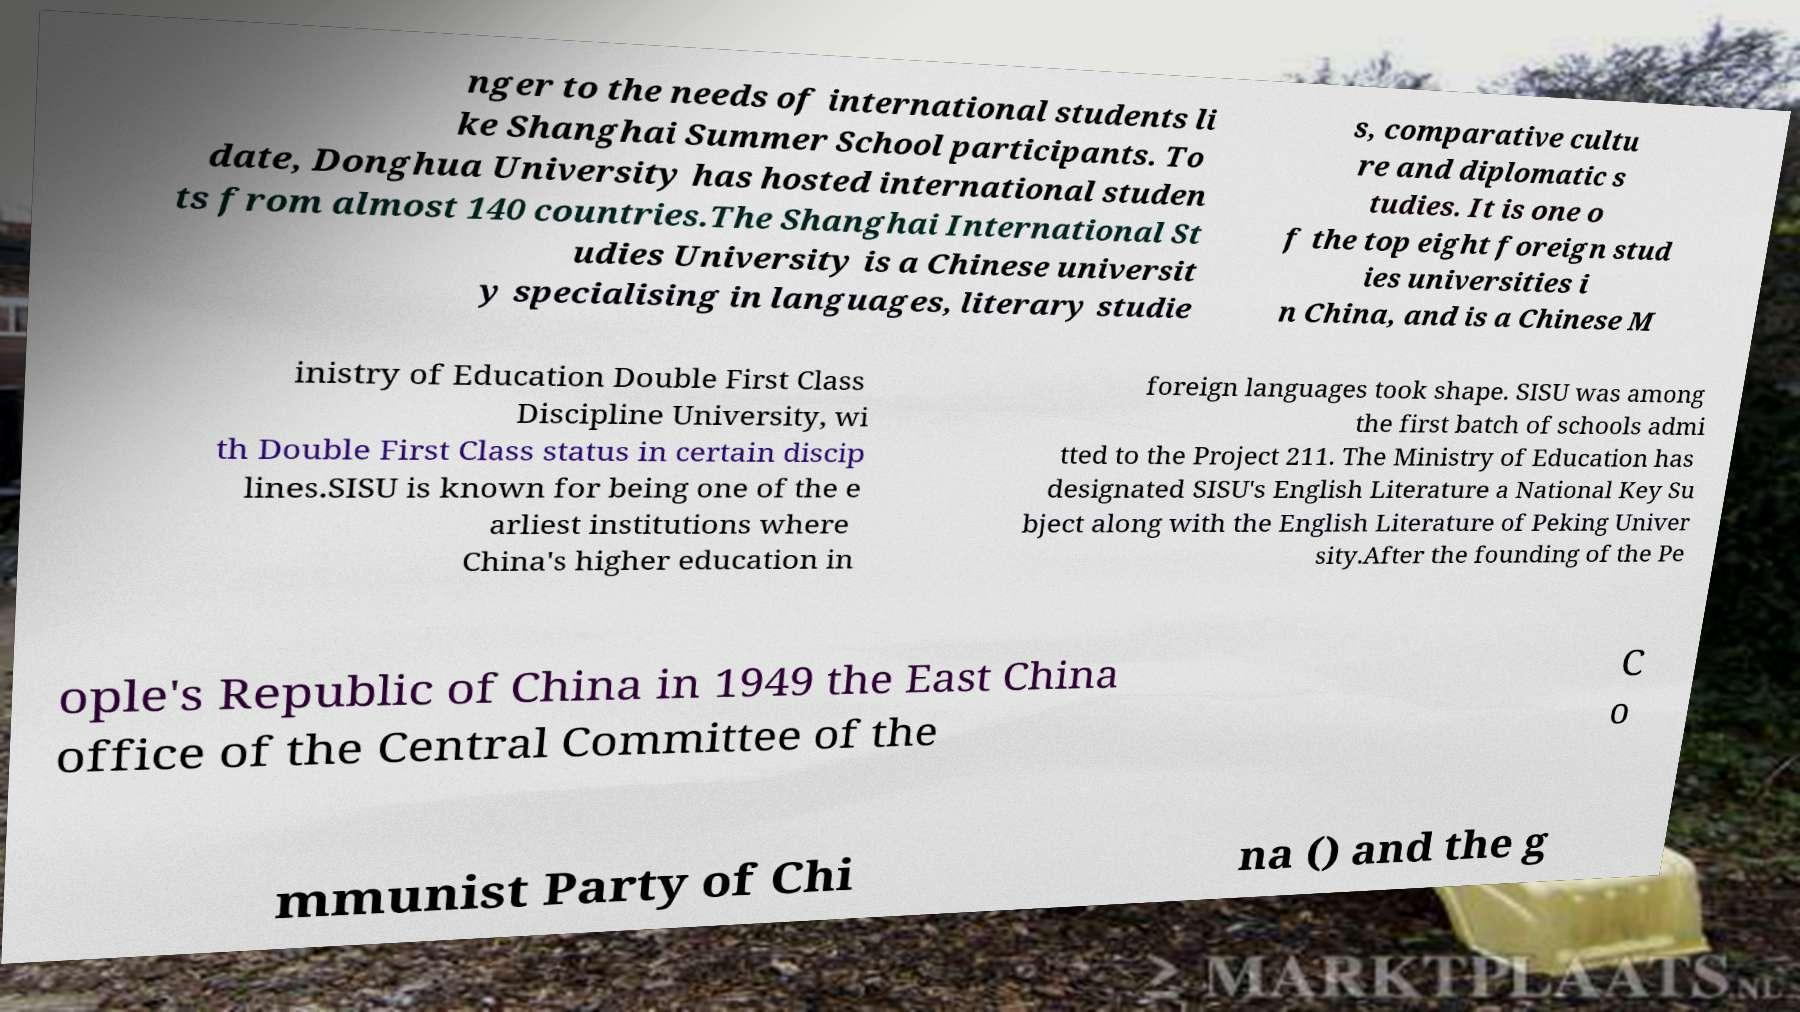For documentation purposes, I need the text within this image transcribed. Could you provide that? nger to the needs of international students li ke Shanghai Summer School participants. To date, Donghua University has hosted international studen ts from almost 140 countries.The Shanghai International St udies University is a Chinese universit y specialising in languages, literary studie s, comparative cultu re and diplomatic s tudies. It is one o f the top eight foreign stud ies universities i n China, and is a Chinese M inistry of Education Double First Class Discipline University, wi th Double First Class status in certain discip lines.SISU is known for being one of the e arliest institutions where China's higher education in foreign languages took shape. SISU was among the first batch of schools admi tted to the Project 211. The Ministry of Education has designated SISU's English Literature a National Key Su bject along with the English Literature of Peking Univer sity.After the founding of the Pe ople's Republic of China in 1949 the East China office of the Central Committee of the C o mmunist Party of Chi na () and the g 